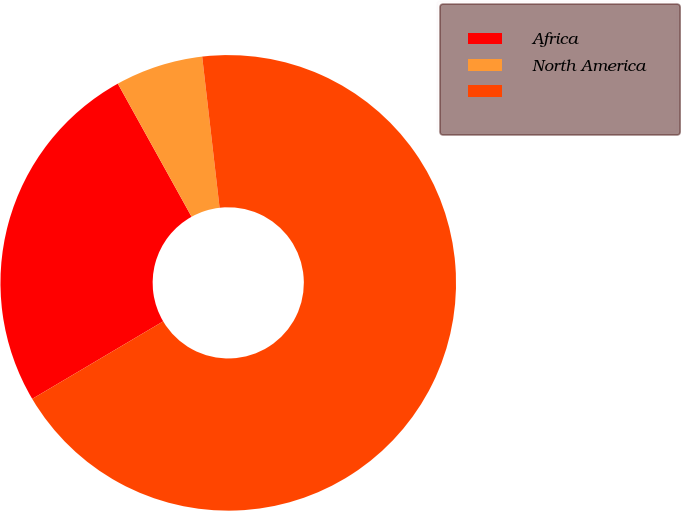Convert chart. <chart><loc_0><loc_0><loc_500><loc_500><pie_chart><fcel>Africa<fcel>North America<fcel>Unnamed: 2<nl><fcel>25.45%<fcel>6.23%<fcel>68.32%<nl></chart> 